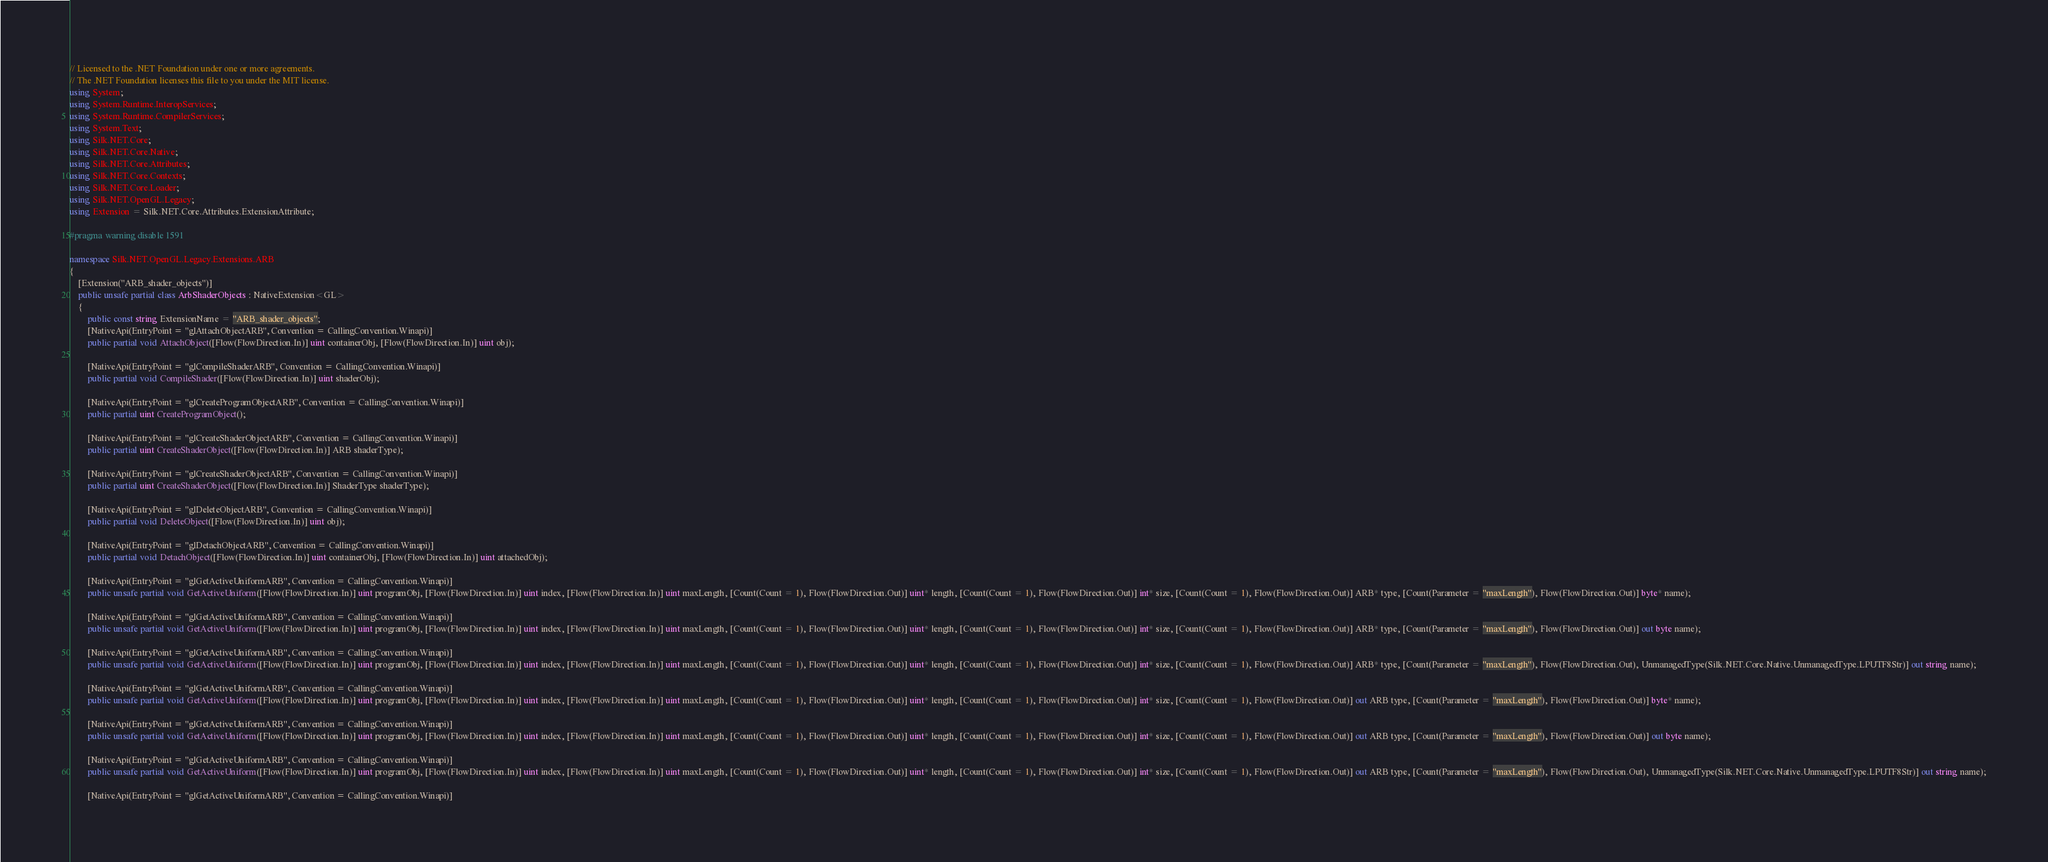<code> <loc_0><loc_0><loc_500><loc_500><_C#_>// Licensed to the .NET Foundation under one or more agreements.
// The .NET Foundation licenses this file to you under the MIT license.
using System;
using System.Runtime.InteropServices;
using System.Runtime.CompilerServices;
using System.Text;
using Silk.NET.Core;
using Silk.NET.Core.Native;
using Silk.NET.Core.Attributes;
using Silk.NET.Core.Contexts;
using Silk.NET.Core.Loader;
using Silk.NET.OpenGL.Legacy;
using Extension = Silk.NET.Core.Attributes.ExtensionAttribute;

#pragma warning disable 1591

namespace Silk.NET.OpenGL.Legacy.Extensions.ARB
{
    [Extension("ARB_shader_objects")]
    public unsafe partial class ArbShaderObjects : NativeExtension<GL>
    {
        public const string ExtensionName = "ARB_shader_objects";
        [NativeApi(EntryPoint = "glAttachObjectARB", Convention = CallingConvention.Winapi)]
        public partial void AttachObject([Flow(FlowDirection.In)] uint containerObj, [Flow(FlowDirection.In)] uint obj);

        [NativeApi(EntryPoint = "glCompileShaderARB", Convention = CallingConvention.Winapi)]
        public partial void CompileShader([Flow(FlowDirection.In)] uint shaderObj);

        [NativeApi(EntryPoint = "glCreateProgramObjectARB", Convention = CallingConvention.Winapi)]
        public partial uint CreateProgramObject();

        [NativeApi(EntryPoint = "glCreateShaderObjectARB", Convention = CallingConvention.Winapi)]
        public partial uint CreateShaderObject([Flow(FlowDirection.In)] ARB shaderType);

        [NativeApi(EntryPoint = "glCreateShaderObjectARB", Convention = CallingConvention.Winapi)]
        public partial uint CreateShaderObject([Flow(FlowDirection.In)] ShaderType shaderType);

        [NativeApi(EntryPoint = "glDeleteObjectARB", Convention = CallingConvention.Winapi)]
        public partial void DeleteObject([Flow(FlowDirection.In)] uint obj);

        [NativeApi(EntryPoint = "glDetachObjectARB", Convention = CallingConvention.Winapi)]
        public partial void DetachObject([Flow(FlowDirection.In)] uint containerObj, [Flow(FlowDirection.In)] uint attachedObj);

        [NativeApi(EntryPoint = "glGetActiveUniformARB", Convention = CallingConvention.Winapi)]
        public unsafe partial void GetActiveUniform([Flow(FlowDirection.In)] uint programObj, [Flow(FlowDirection.In)] uint index, [Flow(FlowDirection.In)] uint maxLength, [Count(Count = 1), Flow(FlowDirection.Out)] uint* length, [Count(Count = 1), Flow(FlowDirection.Out)] int* size, [Count(Count = 1), Flow(FlowDirection.Out)] ARB* type, [Count(Parameter = "maxLength"), Flow(FlowDirection.Out)] byte* name);

        [NativeApi(EntryPoint = "glGetActiveUniformARB", Convention = CallingConvention.Winapi)]
        public unsafe partial void GetActiveUniform([Flow(FlowDirection.In)] uint programObj, [Flow(FlowDirection.In)] uint index, [Flow(FlowDirection.In)] uint maxLength, [Count(Count = 1), Flow(FlowDirection.Out)] uint* length, [Count(Count = 1), Flow(FlowDirection.Out)] int* size, [Count(Count = 1), Flow(FlowDirection.Out)] ARB* type, [Count(Parameter = "maxLength"), Flow(FlowDirection.Out)] out byte name);

        [NativeApi(EntryPoint = "glGetActiveUniformARB", Convention = CallingConvention.Winapi)]
        public unsafe partial void GetActiveUniform([Flow(FlowDirection.In)] uint programObj, [Flow(FlowDirection.In)] uint index, [Flow(FlowDirection.In)] uint maxLength, [Count(Count = 1), Flow(FlowDirection.Out)] uint* length, [Count(Count = 1), Flow(FlowDirection.Out)] int* size, [Count(Count = 1), Flow(FlowDirection.Out)] ARB* type, [Count(Parameter = "maxLength"), Flow(FlowDirection.Out), UnmanagedType(Silk.NET.Core.Native.UnmanagedType.LPUTF8Str)] out string name);

        [NativeApi(EntryPoint = "glGetActiveUniformARB", Convention = CallingConvention.Winapi)]
        public unsafe partial void GetActiveUniform([Flow(FlowDirection.In)] uint programObj, [Flow(FlowDirection.In)] uint index, [Flow(FlowDirection.In)] uint maxLength, [Count(Count = 1), Flow(FlowDirection.Out)] uint* length, [Count(Count = 1), Flow(FlowDirection.Out)] int* size, [Count(Count = 1), Flow(FlowDirection.Out)] out ARB type, [Count(Parameter = "maxLength"), Flow(FlowDirection.Out)] byte* name);

        [NativeApi(EntryPoint = "glGetActiveUniformARB", Convention = CallingConvention.Winapi)]
        public unsafe partial void GetActiveUniform([Flow(FlowDirection.In)] uint programObj, [Flow(FlowDirection.In)] uint index, [Flow(FlowDirection.In)] uint maxLength, [Count(Count = 1), Flow(FlowDirection.Out)] uint* length, [Count(Count = 1), Flow(FlowDirection.Out)] int* size, [Count(Count = 1), Flow(FlowDirection.Out)] out ARB type, [Count(Parameter = "maxLength"), Flow(FlowDirection.Out)] out byte name);

        [NativeApi(EntryPoint = "glGetActiveUniformARB", Convention = CallingConvention.Winapi)]
        public unsafe partial void GetActiveUniform([Flow(FlowDirection.In)] uint programObj, [Flow(FlowDirection.In)] uint index, [Flow(FlowDirection.In)] uint maxLength, [Count(Count = 1), Flow(FlowDirection.Out)] uint* length, [Count(Count = 1), Flow(FlowDirection.Out)] int* size, [Count(Count = 1), Flow(FlowDirection.Out)] out ARB type, [Count(Parameter = "maxLength"), Flow(FlowDirection.Out), UnmanagedType(Silk.NET.Core.Native.UnmanagedType.LPUTF8Str)] out string name);

        [NativeApi(EntryPoint = "glGetActiveUniformARB", Convention = CallingConvention.Winapi)]</code> 